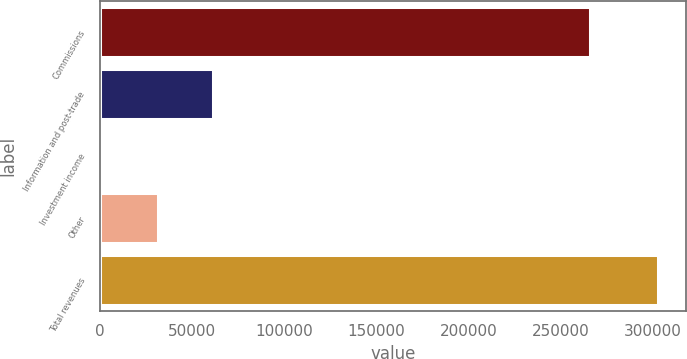Convert chart to OTSL. <chart><loc_0><loc_0><loc_500><loc_500><bar_chart><fcel>Commissions<fcel>Information and post-trade<fcel>Investment income<fcel>Other<fcel>Total revenues<nl><fcel>266221<fcel>61343.6<fcel>905<fcel>31124.3<fcel>303098<nl></chart> 